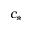Convert formula to latex. <formula><loc_0><loc_0><loc_500><loc_500>c _ { * }</formula> 